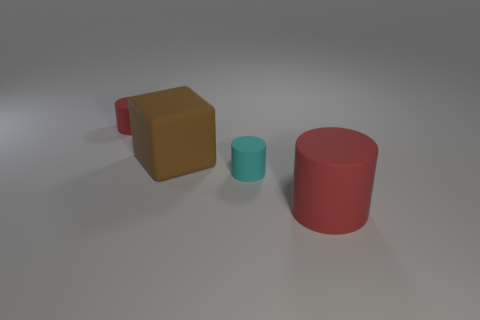Are there any small matte objects that have the same color as the big cylinder?
Offer a very short reply. Yes. The other rubber cylinder that is the same color as the large matte cylinder is what size?
Make the answer very short. Small. Is the number of tiny cyan rubber cylinders that are left of the big brown rubber object less than the number of large red rubber objects?
Give a very brief answer. Yes. There is a tiny cylinder on the right side of the red cylinder that is to the left of the brown block; what is its color?
Ensure brevity in your answer.  Cyan. There is a red matte cylinder in front of the small matte object that is right of the large object that is behind the large red object; how big is it?
Ensure brevity in your answer.  Large. Is the number of small rubber things on the right side of the big red rubber thing less than the number of brown rubber blocks that are behind the big brown rubber thing?
Make the answer very short. No. What number of small cyan cylinders have the same material as the small red cylinder?
Your response must be concise. 1. Are there any matte objects that are right of the small thing in front of the small cylinder to the left of the matte cube?
Ensure brevity in your answer.  Yes. What shape is the small red thing that is made of the same material as the big red cylinder?
Provide a short and direct response. Cylinder. Are there more red rubber objects than cylinders?
Make the answer very short. No. 